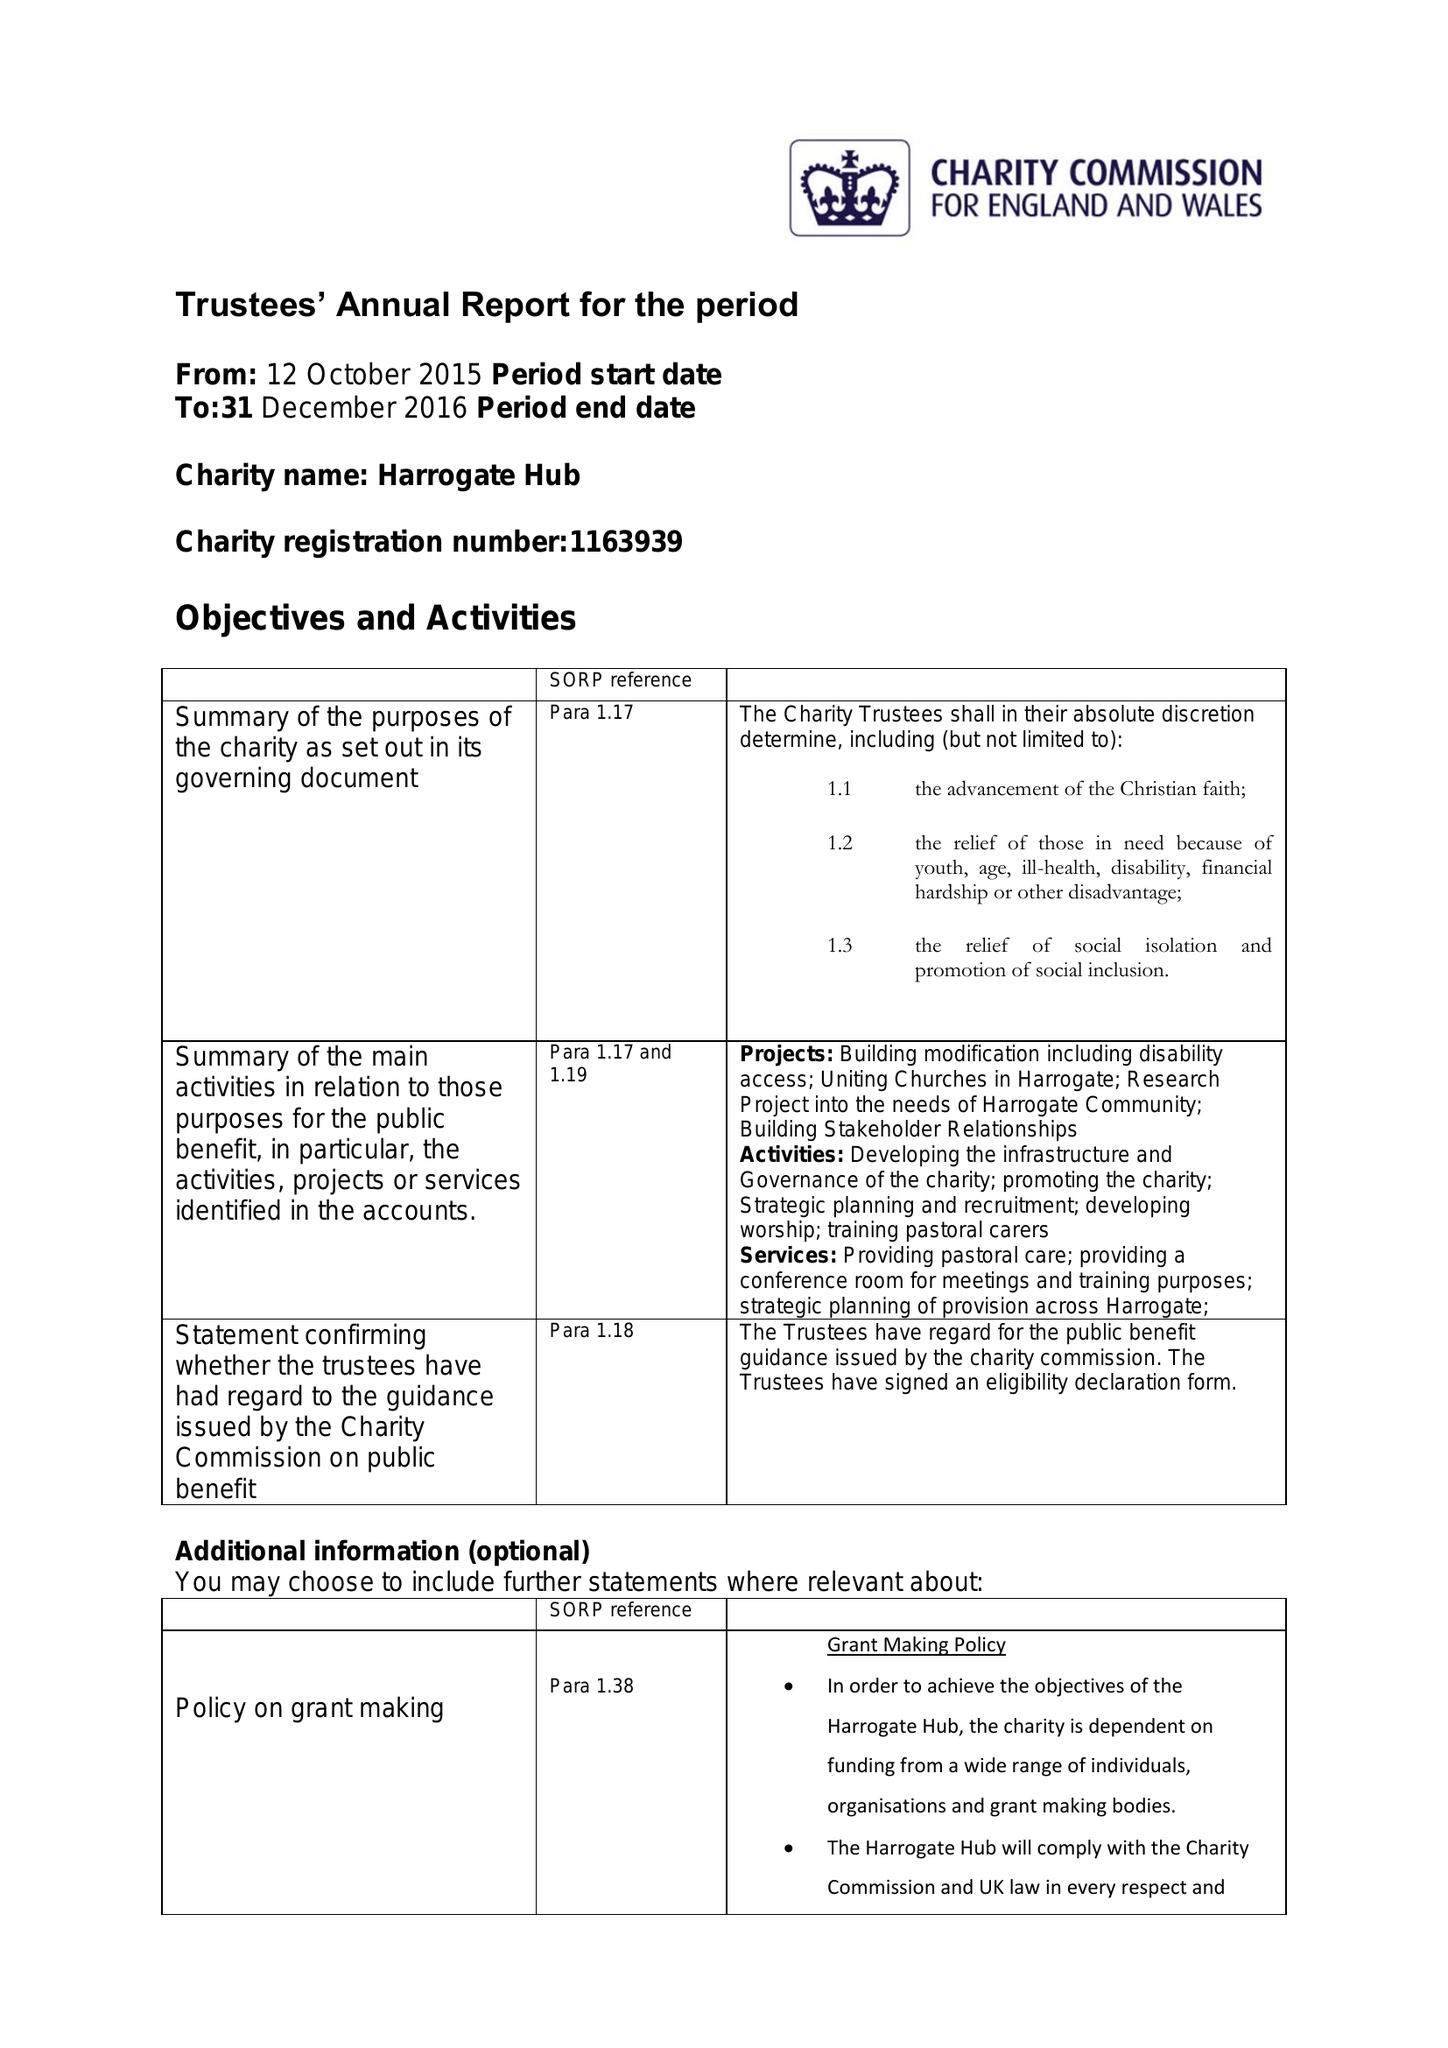What is the value for the charity_number?
Answer the question using a single word or phrase. 1163939 